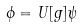Convert formula to latex. <formula><loc_0><loc_0><loc_500><loc_500>\phi = U [ g ] \psi</formula> 